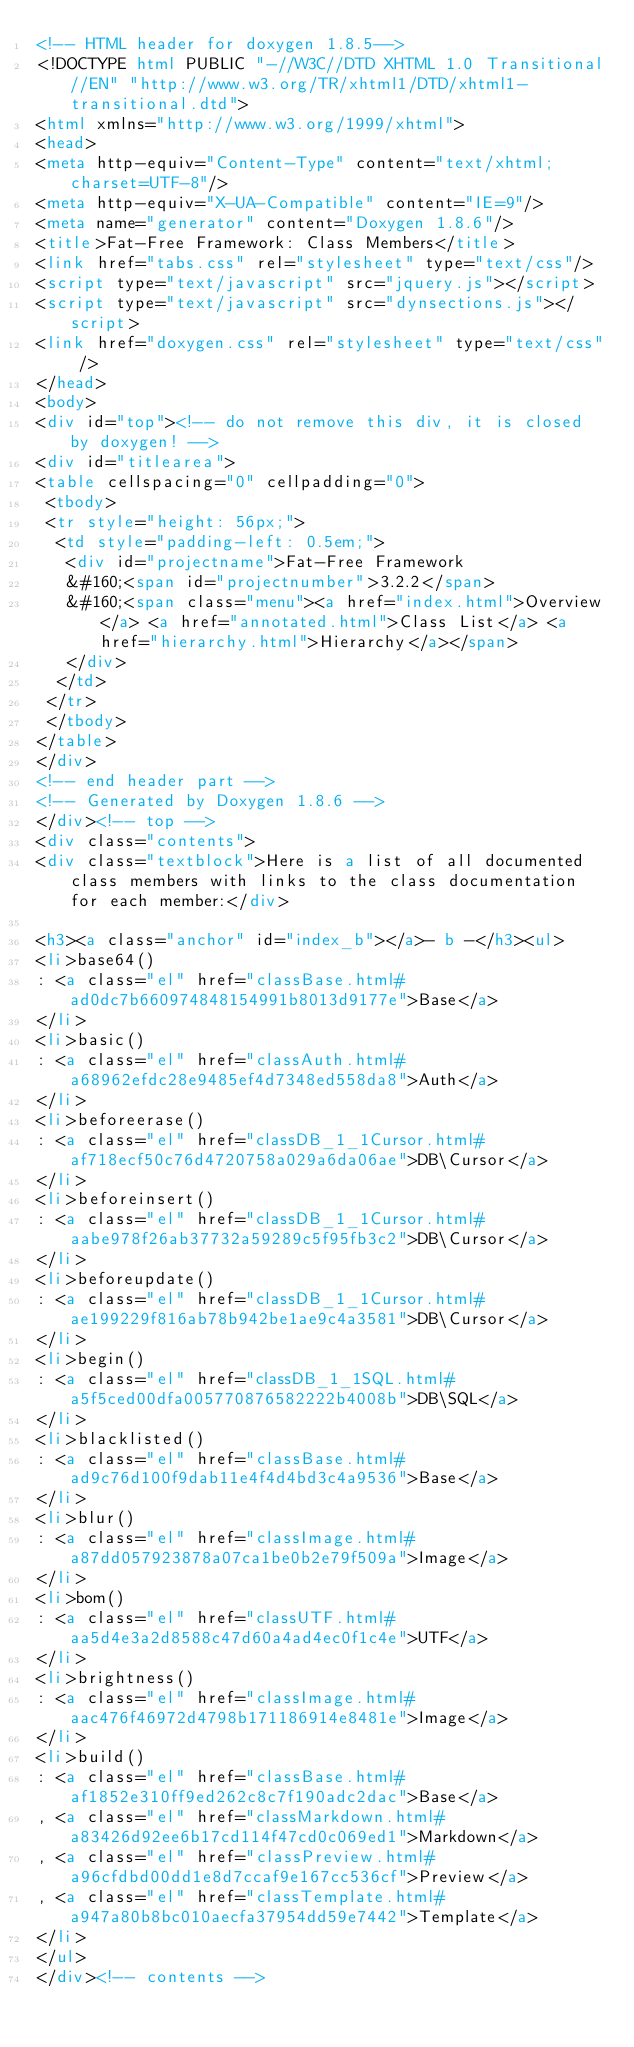Convert code to text. <code><loc_0><loc_0><loc_500><loc_500><_HTML_><!-- HTML header for doxygen 1.8.5-->
<!DOCTYPE html PUBLIC "-//W3C//DTD XHTML 1.0 Transitional//EN" "http://www.w3.org/TR/xhtml1/DTD/xhtml1-transitional.dtd">
<html xmlns="http://www.w3.org/1999/xhtml">
<head>
<meta http-equiv="Content-Type" content="text/xhtml;charset=UTF-8"/>
<meta http-equiv="X-UA-Compatible" content="IE=9"/>
<meta name="generator" content="Doxygen 1.8.6"/>
<title>Fat-Free Framework: Class Members</title>
<link href="tabs.css" rel="stylesheet" type="text/css"/>
<script type="text/javascript" src="jquery.js"></script>
<script type="text/javascript" src="dynsections.js"></script>
<link href="doxygen.css" rel="stylesheet" type="text/css" />
</head>
<body>
<div id="top"><!-- do not remove this div, it is closed by doxygen! -->
<div id="titlearea">
<table cellspacing="0" cellpadding="0">
 <tbody>
 <tr style="height: 56px;">
  <td style="padding-left: 0.5em;">
   <div id="projectname">Fat-Free Framework
   &#160;<span id="projectnumber">3.2.2</span>
   &#160;<span class="menu"><a href="index.html">Overview</a> <a href="annotated.html">Class List</a> <a href="hierarchy.html">Hierarchy</a></span>
   </div>
  </td>
 </tr>
 </tbody>
</table>
</div>
<!-- end header part -->
<!-- Generated by Doxygen 1.8.6 -->
</div><!-- top -->
<div class="contents">
<div class="textblock">Here is a list of all documented class members with links to the class documentation for each member:</div>

<h3><a class="anchor" id="index_b"></a>- b -</h3><ul>
<li>base64()
: <a class="el" href="classBase.html#ad0dc7b660974848154991b8013d9177e">Base</a>
</li>
<li>basic()
: <a class="el" href="classAuth.html#a68962efdc28e9485ef4d7348ed558da8">Auth</a>
</li>
<li>beforeerase()
: <a class="el" href="classDB_1_1Cursor.html#af718ecf50c76d4720758a029a6da06ae">DB\Cursor</a>
</li>
<li>beforeinsert()
: <a class="el" href="classDB_1_1Cursor.html#aabe978f26ab37732a59289c5f95fb3c2">DB\Cursor</a>
</li>
<li>beforeupdate()
: <a class="el" href="classDB_1_1Cursor.html#ae199229f816ab78b942be1ae9c4a3581">DB\Cursor</a>
</li>
<li>begin()
: <a class="el" href="classDB_1_1SQL.html#a5f5ced00dfa005770876582222b4008b">DB\SQL</a>
</li>
<li>blacklisted()
: <a class="el" href="classBase.html#ad9c76d100f9dab11e4f4d4bd3c4a9536">Base</a>
</li>
<li>blur()
: <a class="el" href="classImage.html#a87dd057923878a07ca1be0b2e79f509a">Image</a>
</li>
<li>bom()
: <a class="el" href="classUTF.html#aa5d4e3a2d8588c47d60a4ad4ec0f1c4e">UTF</a>
</li>
<li>brightness()
: <a class="el" href="classImage.html#aac476f46972d4798b171186914e8481e">Image</a>
</li>
<li>build()
: <a class="el" href="classBase.html#af1852e310ff9ed262c8c7f190adc2dac">Base</a>
, <a class="el" href="classMarkdown.html#a83426d92ee6b17cd114f47cd0c069ed1">Markdown</a>
, <a class="el" href="classPreview.html#a96cfdbd00dd1e8d7ccaf9e167cc536cf">Preview</a>
, <a class="el" href="classTemplate.html#a947a80b8bc010aecfa37954dd59e7442">Template</a>
</li>
</ul>
</div><!-- contents -->
</code> 